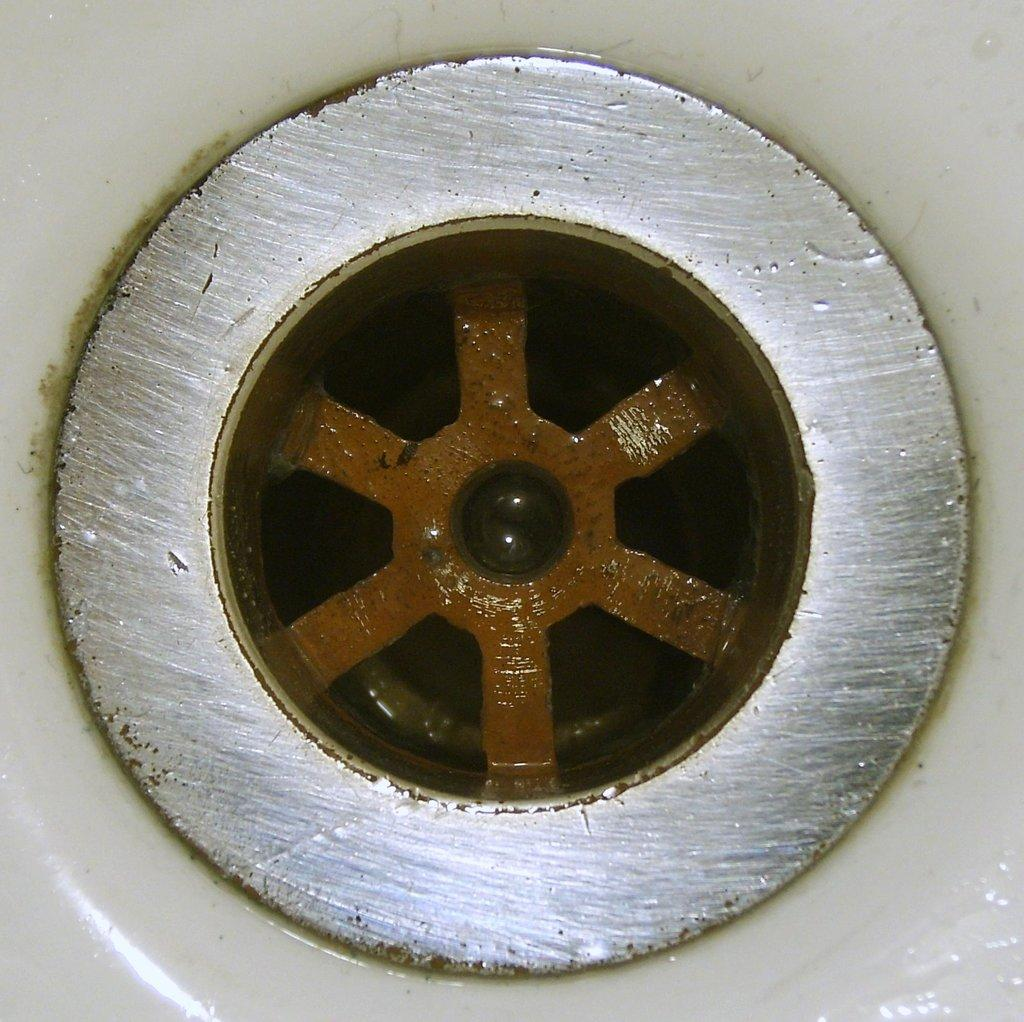What is the main subject of the image? The main subject of the image is the waste coupling of a sink. Can you describe the waste coupling in more detail? Unfortunately, the provided facts do not offer any additional details about the waste coupling. What kind of relationship does the waste coupling have with the sink's mom in the image? There is no mention of a sink's mom in the image or the provided facts, so it is not possible to answer this question. 